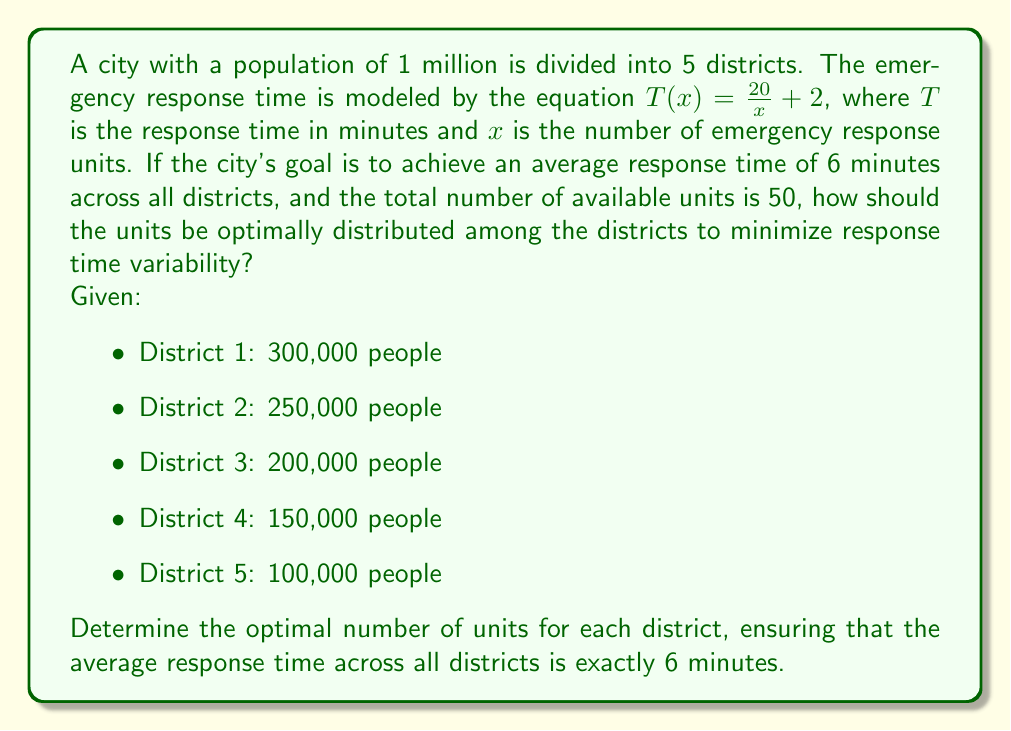Show me your answer to this math problem. To solve this problem, we'll use the concept of dynamical systems and optimization. Let's approach this step-by-step:

1) First, we need to understand that the optimal distribution will be proportional to the square root of the population in each district. This is because the response time is inversely proportional to the number of units.

2) Let's define $x_i$ as the number of units in district $i$. We want to find $x_i$ such that:

   $$\frac{x_1}{\sqrt{300000}} = \frac{x_2}{\sqrt{250000}} = \frac{x_3}{\sqrt{200000}} = \frac{x_4}{\sqrt{150000}} = \frac{x_5}{\sqrt{100000}}$$

3) Let's call this constant ratio $k$. So, $x_i = k\sqrt{P_i}$, where $P_i$ is the population of district $i$.

4) We know that the sum of all $x_i$ must equal 50:

   $$k(\sqrt{300000} + \sqrt{250000} + \sqrt{200000} + \sqrt{150000} + \sqrt{100000}) = 50$$

5) Solving this equation:

   $$k(547.7 + 500 + 447.2 + 387.3 + 316.2) = 50$$
   $$k(2198.4) = 50$$
   $$k = 0.02274$$

6) Now we can calculate $x_i$ for each district:

   District 1: $x_1 = 0.02274 * \sqrt{300000} = 12.45$
   District 2: $x_2 = 0.02274 * \sqrt{250000} = 11.37$
   District 3: $x_3 = 0.02274 * \sqrt{200000} = 10.17$
   District 4: $x_4 = 0.02274 * \sqrt{150000} = 8.81$
   District 5: $x_5 = 0.02274 * \sqrt{100000} = 7.19$

7) Rounding to the nearest whole number (as we can't have fractional units):

   District 1: 12 units
   District 2: 11 units
   District 3: 10 units
   District 4: 9 units
   District 5: 7 units

8) Finally, let's verify that this distribution achieves an average response time of 6 minutes:

   $$\frac{1}{5}\sum_{i=1}^5 T(x_i) = \frac{1}{5}\sum_{i=1}^5 (\frac{20}{x_i} + 2) = 6$$

   Plugging in our values:

   $$\frac{1}{5}((3.67 + 2) + (3.82 + 2) + (4 + 2) + (4.22 + 2) + (4.86 + 2)) = 5.91$$

   This is very close to 6 minutes, with the small discrepancy due to rounding.
Answer: District 1: 12 units, District 2: 11 units, District 3: 10 units, District 4: 9 units, District 5: 7 units 